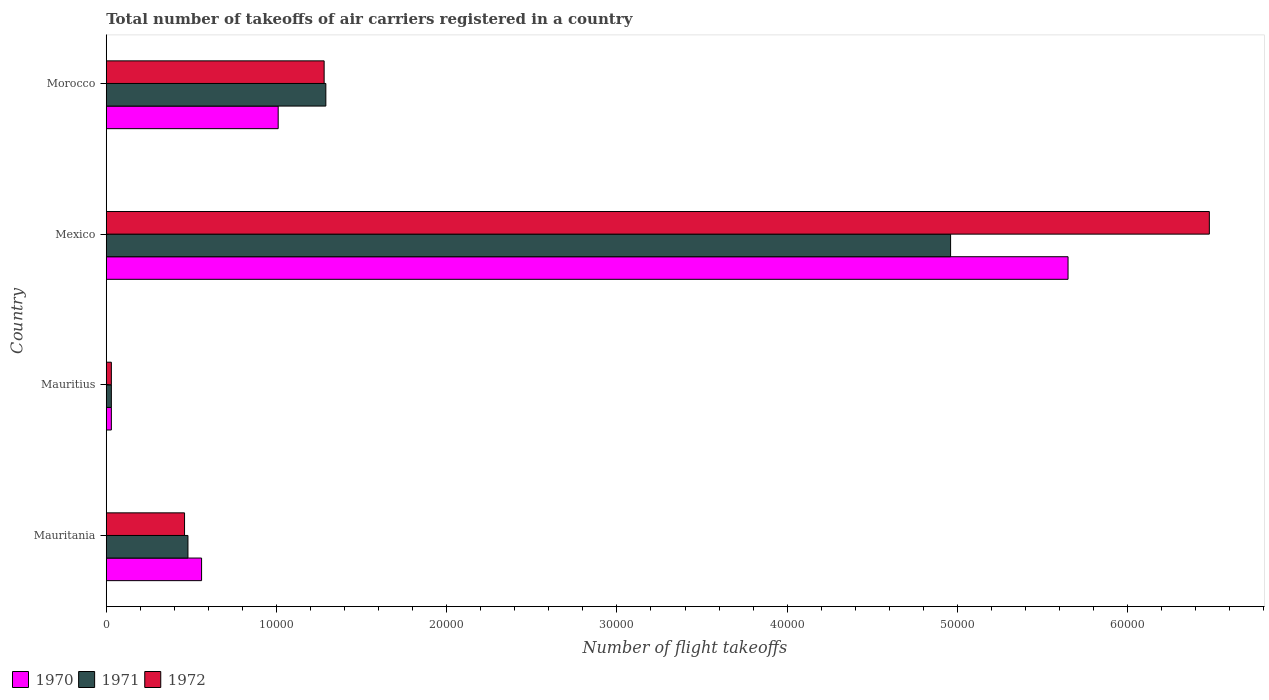How many different coloured bars are there?
Give a very brief answer. 3. How many groups of bars are there?
Your response must be concise. 4. Are the number of bars per tick equal to the number of legend labels?
Your answer should be compact. Yes. Are the number of bars on each tick of the Y-axis equal?
Your response must be concise. Yes. What is the label of the 3rd group of bars from the top?
Your response must be concise. Mauritius. What is the total number of flight takeoffs in 1972 in Mauritania?
Ensure brevity in your answer.  4600. Across all countries, what is the maximum total number of flight takeoffs in 1970?
Make the answer very short. 5.65e+04. Across all countries, what is the minimum total number of flight takeoffs in 1970?
Provide a succinct answer. 300. In which country was the total number of flight takeoffs in 1970 minimum?
Make the answer very short. Mauritius. What is the total total number of flight takeoffs in 1970 in the graph?
Offer a very short reply. 7.25e+04. What is the difference between the total number of flight takeoffs in 1971 in Mauritius and that in Morocco?
Provide a succinct answer. -1.26e+04. What is the difference between the total number of flight takeoffs in 1970 in Mauritius and the total number of flight takeoffs in 1972 in Mauritania?
Offer a terse response. -4300. What is the average total number of flight takeoffs in 1970 per country?
Your response must be concise. 1.81e+04. What is the difference between the total number of flight takeoffs in 1970 and total number of flight takeoffs in 1972 in Morocco?
Make the answer very short. -2700. In how many countries, is the total number of flight takeoffs in 1970 greater than 12000 ?
Keep it short and to the point. 1. What is the ratio of the total number of flight takeoffs in 1971 in Mauritius to that in Mexico?
Keep it short and to the point. 0.01. Is the total number of flight takeoffs in 1970 in Mauritius less than that in Morocco?
Offer a very short reply. Yes. Is the difference between the total number of flight takeoffs in 1970 in Mauritius and Mexico greater than the difference between the total number of flight takeoffs in 1972 in Mauritius and Mexico?
Offer a terse response. Yes. What is the difference between the highest and the second highest total number of flight takeoffs in 1970?
Your response must be concise. 4.64e+04. What is the difference between the highest and the lowest total number of flight takeoffs in 1970?
Provide a succinct answer. 5.62e+04. In how many countries, is the total number of flight takeoffs in 1970 greater than the average total number of flight takeoffs in 1970 taken over all countries?
Make the answer very short. 1. What does the 2nd bar from the bottom in Mauritius represents?
Offer a very short reply. 1971. Is it the case that in every country, the sum of the total number of flight takeoffs in 1970 and total number of flight takeoffs in 1972 is greater than the total number of flight takeoffs in 1971?
Give a very brief answer. Yes. Are all the bars in the graph horizontal?
Offer a terse response. Yes. What is the difference between two consecutive major ticks on the X-axis?
Offer a terse response. 10000. Where does the legend appear in the graph?
Offer a terse response. Bottom left. How many legend labels are there?
Your response must be concise. 3. What is the title of the graph?
Your response must be concise. Total number of takeoffs of air carriers registered in a country. What is the label or title of the X-axis?
Ensure brevity in your answer.  Number of flight takeoffs. What is the label or title of the Y-axis?
Your response must be concise. Country. What is the Number of flight takeoffs of 1970 in Mauritania?
Offer a terse response. 5600. What is the Number of flight takeoffs in 1971 in Mauritania?
Give a very brief answer. 4800. What is the Number of flight takeoffs of 1972 in Mauritania?
Your answer should be compact. 4600. What is the Number of flight takeoffs of 1970 in Mauritius?
Your answer should be very brief. 300. What is the Number of flight takeoffs of 1971 in Mauritius?
Offer a terse response. 300. What is the Number of flight takeoffs of 1972 in Mauritius?
Offer a very short reply. 300. What is the Number of flight takeoffs of 1970 in Mexico?
Provide a succinct answer. 5.65e+04. What is the Number of flight takeoffs of 1971 in Mexico?
Ensure brevity in your answer.  4.96e+04. What is the Number of flight takeoffs in 1972 in Mexico?
Make the answer very short. 6.48e+04. What is the Number of flight takeoffs in 1970 in Morocco?
Offer a very short reply. 1.01e+04. What is the Number of flight takeoffs in 1971 in Morocco?
Ensure brevity in your answer.  1.29e+04. What is the Number of flight takeoffs of 1972 in Morocco?
Offer a terse response. 1.28e+04. Across all countries, what is the maximum Number of flight takeoffs in 1970?
Offer a terse response. 5.65e+04. Across all countries, what is the maximum Number of flight takeoffs of 1971?
Keep it short and to the point. 4.96e+04. Across all countries, what is the maximum Number of flight takeoffs of 1972?
Make the answer very short. 6.48e+04. Across all countries, what is the minimum Number of flight takeoffs in 1970?
Give a very brief answer. 300. Across all countries, what is the minimum Number of flight takeoffs in 1971?
Your answer should be very brief. 300. Across all countries, what is the minimum Number of flight takeoffs in 1972?
Keep it short and to the point. 300. What is the total Number of flight takeoffs in 1970 in the graph?
Offer a very short reply. 7.25e+04. What is the total Number of flight takeoffs of 1971 in the graph?
Your answer should be very brief. 6.76e+04. What is the total Number of flight takeoffs of 1972 in the graph?
Your answer should be compact. 8.25e+04. What is the difference between the Number of flight takeoffs in 1970 in Mauritania and that in Mauritius?
Your answer should be very brief. 5300. What is the difference between the Number of flight takeoffs of 1971 in Mauritania and that in Mauritius?
Your answer should be compact. 4500. What is the difference between the Number of flight takeoffs of 1972 in Mauritania and that in Mauritius?
Offer a terse response. 4300. What is the difference between the Number of flight takeoffs of 1970 in Mauritania and that in Mexico?
Provide a short and direct response. -5.09e+04. What is the difference between the Number of flight takeoffs in 1971 in Mauritania and that in Mexico?
Keep it short and to the point. -4.48e+04. What is the difference between the Number of flight takeoffs in 1972 in Mauritania and that in Mexico?
Ensure brevity in your answer.  -6.02e+04. What is the difference between the Number of flight takeoffs in 1970 in Mauritania and that in Morocco?
Keep it short and to the point. -4500. What is the difference between the Number of flight takeoffs of 1971 in Mauritania and that in Morocco?
Give a very brief answer. -8100. What is the difference between the Number of flight takeoffs in 1972 in Mauritania and that in Morocco?
Offer a very short reply. -8200. What is the difference between the Number of flight takeoffs in 1970 in Mauritius and that in Mexico?
Offer a very short reply. -5.62e+04. What is the difference between the Number of flight takeoffs of 1971 in Mauritius and that in Mexico?
Make the answer very short. -4.93e+04. What is the difference between the Number of flight takeoffs in 1972 in Mauritius and that in Mexico?
Keep it short and to the point. -6.45e+04. What is the difference between the Number of flight takeoffs in 1970 in Mauritius and that in Morocco?
Ensure brevity in your answer.  -9800. What is the difference between the Number of flight takeoffs in 1971 in Mauritius and that in Morocco?
Ensure brevity in your answer.  -1.26e+04. What is the difference between the Number of flight takeoffs in 1972 in Mauritius and that in Morocco?
Your answer should be compact. -1.25e+04. What is the difference between the Number of flight takeoffs in 1970 in Mexico and that in Morocco?
Keep it short and to the point. 4.64e+04. What is the difference between the Number of flight takeoffs in 1971 in Mexico and that in Morocco?
Make the answer very short. 3.67e+04. What is the difference between the Number of flight takeoffs of 1972 in Mexico and that in Morocco?
Give a very brief answer. 5.20e+04. What is the difference between the Number of flight takeoffs in 1970 in Mauritania and the Number of flight takeoffs in 1971 in Mauritius?
Ensure brevity in your answer.  5300. What is the difference between the Number of flight takeoffs in 1970 in Mauritania and the Number of flight takeoffs in 1972 in Mauritius?
Keep it short and to the point. 5300. What is the difference between the Number of flight takeoffs in 1971 in Mauritania and the Number of flight takeoffs in 1972 in Mauritius?
Your answer should be compact. 4500. What is the difference between the Number of flight takeoffs of 1970 in Mauritania and the Number of flight takeoffs of 1971 in Mexico?
Offer a terse response. -4.40e+04. What is the difference between the Number of flight takeoffs in 1970 in Mauritania and the Number of flight takeoffs in 1972 in Mexico?
Provide a succinct answer. -5.92e+04. What is the difference between the Number of flight takeoffs of 1971 in Mauritania and the Number of flight takeoffs of 1972 in Mexico?
Your answer should be very brief. -6.00e+04. What is the difference between the Number of flight takeoffs of 1970 in Mauritania and the Number of flight takeoffs of 1971 in Morocco?
Keep it short and to the point. -7300. What is the difference between the Number of flight takeoffs in 1970 in Mauritania and the Number of flight takeoffs in 1972 in Morocco?
Give a very brief answer. -7200. What is the difference between the Number of flight takeoffs in 1971 in Mauritania and the Number of flight takeoffs in 1972 in Morocco?
Make the answer very short. -8000. What is the difference between the Number of flight takeoffs in 1970 in Mauritius and the Number of flight takeoffs in 1971 in Mexico?
Your answer should be compact. -4.93e+04. What is the difference between the Number of flight takeoffs of 1970 in Mauritius and the Number of flight takeoffs of 1972 in Mexico?
Your answer should be compact. -6.45e+04. What is the difference between the Number of flight takeoffs in 1971 in Mauritius and the Number of flight takeoffs in 1972 in Mexico?
Provide a short and direct response. -6.45e+04. What is the difference between the Number of flight takeoffs in 1970 in Mauritius and the Number of flight takeoffs in 1971 in Morocco?
Keep it short and to the point. -1.26e+04. What is the difference between the Number of flight takeoffs of 1970 in Mauritius and the Number of flight takeoffs of 1972 in Morocco?
Offer a terse response. -1.25e+04. What is the difference between the Number of flight takeoffs in 1971 in Mauritius and the Number of flight takeoffs in 1972 in Morocco?
Your response must be concise. -1.25e+04. What is the difference between the Number of flight takeoffs of 1970 in Mexico and the Number of flight takeoffs of 1971 in Morocco?
Provide a short and direct response. 4.36e+04. What is the difference between the Number of flight takeoffs of 1970 in Mexico and the Number of flight takeoffs of 1972 in Morocco?
Your answer should be compact. 4.37e+04. What is the difference between the Number of flight takeoffs in 1971 in Mexico and the Number of flight takeoffs in 1972 in Morocco?
Your response must be concise. 3.68e+04. What is the average Number of flight takeoffs of 1970 per country?
Your response must be concise. 1.81e+04. What is the average Number of flight takeoffs in 1971 per country?
Ensure brevity in your answer.  1.69e+04. What is the average Number of flight takeoffs in 1972 per country?
Your answer should be very brief. 2.06e+04. What is the difference between the Number of flight takeoffs in 1970 and Number of flight takeoffs in 1971 in Mauritania?
Offer a terse response. 800. What is the difference between the Number of flight takeoffs in 1970 and Number of flight takeoffs in 1972 in Mauritania?
Offer a terse response. 1000. What is the difference between the Number of flight takeoffs in 1971 and Number of flight takeoffs in 1972 in Mauritania?
Offer a terse response. 200. What is the difference between the Number of flight takeoffs of 1970 and Number of flight takeoffs of 1971 in Mauritius?
Give a very brief answer. 0. What is the difference between the Number of flight takeoffs in 1971 and Number of flight takeoffs in 1972 in Mauritius?
Your answer should be very brief. 0. What is the difference between the Number of flight takeoffs in 1970 and Number of flight takeoffs in 1971 in Mexico?
Your answer should be very brief. 6900. What is the difference between the Number of flight takeoffs in 1970 and Number of flight takeoffs in 1972 in Mexico?
Your answer should be very brief. -8300. What is the difference between the Number of flight takeoffs in 1971 and Number of flight takeoffs in 1972 in Mexico?
Give a very brief answer. -1.52e+04. What is the difference between the Number of flight takeoffs in 1970 and Number of flight takeoffs in 1971 in Morocco?
Keep it short and to the point. -2800. What is the difference between the Number of flight takeoffs of 1970 and Number of flight takeoffs of 1972 in Morocco?
Give a very brief answer. -2700. What is the difference between the Number of flight takeoffs of 1971 and Number of flight takeoffs of 1972 in Morocco?
Offer a very short reply. 100. What is the ratio of the Number of flight takeoffs of 1970 in Mauritania to that in Mauritius?
Your response must be concise. 18.67. What is the ratio of the Number of flight takeoffs of 1971 in Mauritania to that in Mauritius?
Offer a very short reply. 16. What is the ratio of the Number of flight takeoffs in 1972 in Mauritania to that in Mauritius?
Ensure brevity in your answer.  15.33. What is the ratio of the Number of flight takeoffs in 1970 in Mauritania to that in Mexico?
Make the answer very short. 0.1. What is the ratio of the Number of flight takeoffs of 1971 in Mauritania to that in Mexico?
Keep it short and to the point. 0.1. What is the ratio of the Number of flight takeoffs of 1972 in Mauritania to that in Mexico?
Your response must be concise. 0.07. What is the ratio of the Number of flight takeoffs in 1970 in Mauritania to that in Morocco?
Ensure brevity in your answer.  0.55. What is the ratio of the Number of flight takeoffs in 1971 in Mauritania to that in Morocco?
Your response must be concise. 0.37. What is the ratio of the Number of flight takeoffs in 1972 in Mauritania to that in Morocco?
Ensure brevity in your answer.  0.36. What is the ratio of the Number of flight takeoffs in 1970 in Mauritius to that in Mexico?
Make the answer very short. 0.01. What is the ratio of the Number of flight takeoffs in 1971 in Mauritius to that in Mexico?
Offer a very short reply. 0.01. What is the ratio of the Number of flight takeoffs of 1972 in Mauritius to that in Mexico?
Your response must be concise. 0. What is the ratio of the Number of flight takeoffs of 1970 in Mauritius to that in Morocco?
Ensure brevity in your answer.  0.03. What is the ratio of the Number of flight takeoffs in 1971 in Mauritius to that in Morocco?
Offer a very short reply. 0.02. What is the ratio of the Number of flight takeoffs of 1972 in Mauritius to that in Morocco?
Offer a very short reply. 0.02. What is the ratio of the Number of flight takeoffs in 1970 in Mexico to that in Morocco?
Your answer should be compact. 5.59. What is the ratio of the Number of flight takeoffs of 1971 in Mexico to that in Morocco?
Give a very brief answer. 3.85. What is the ratio of the Number of flight takeoffs in 1972 in Mexico to that in Morocco?
Ensure brevity in your answer.  5.06. What is the difference between the highest and the second highest Number of flight takeoffs of 1970?
Provide a succinct answer. 4.64e+04. What is the difference between the highest and the second highest Number of flight takeoffs in 1971?
Make the answer very short. 3.67e+04. What is the difference between the highest and the second highest Number of flight takeoffs in 1972?
Your answer should be very brief. 5.20e+04. What is the difference between the highest and the lowest Number of flight takeoffs in 1970?
Your response must be concise. 5.62e+04. What is the difference between the highest and the lowest Number of flight takeoffs in 1971?
Provide a short and direct response. 4.93e+04. What is the difference between the highest and the lowest Number of flight takeoffs in 1972?
Ensure brevity in your answer.  6.45e+04. 